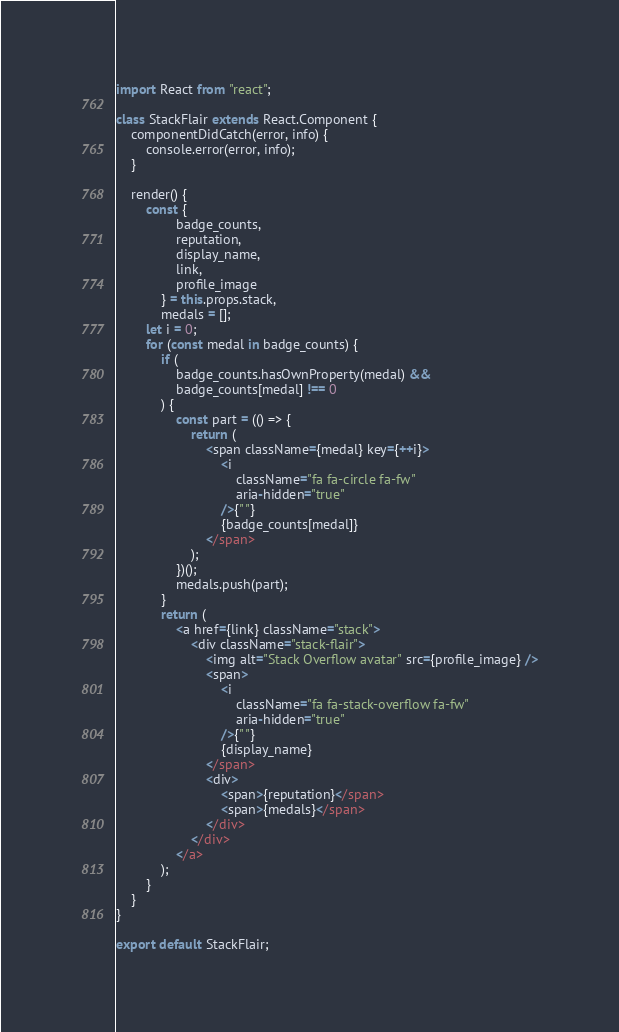<code> <loc_0><loc_0><loc_500><loc_500><_JavaScript_>import React from "react";

class StackFlair extends React.Component {
    componentDidCatch(error, info) {
        console.error(error, info);
    }

    render() {
        const {
                badge_counts,
                reputation,
                display_name,
                link,
                profile_image
            } = this.props.stack,
            medals = [];
        let i = 0;
        for (const medal in badge_counts) {
            if (
                badge_counts.hasOwnProperty(medal) &&
                badge_counts[medal] !== 0
            ) {
                const part = (() => {
                    return (
                        <span className={medal} key={++i}>
                            <i
                                className="fa fa-circle fa-fw"
                                aria-hidden="true"
                            />{" "}
                            {badge_counts[medal]}
                        </span>
                    );
                })();
                medals.push(part);
            }
            return (
                <a href={link} className="stack">
                    <div className="stack-flair">
                        <img alt="Stack Overflow avatar" src={profile_image} />
                        <span>
                            <i
                                className="fa fa-stack-overflow fa-fw"
                                aria-hidden="true"
                            />{" "}
                            {display_name}
                        </span>
                        <div>
                            <span>{reputation}</span>
                            <span>{medals}</span>
                        </div>
                    </div>
                </a>
            );
        }
    }
}

export default StackFlair;
</code> 